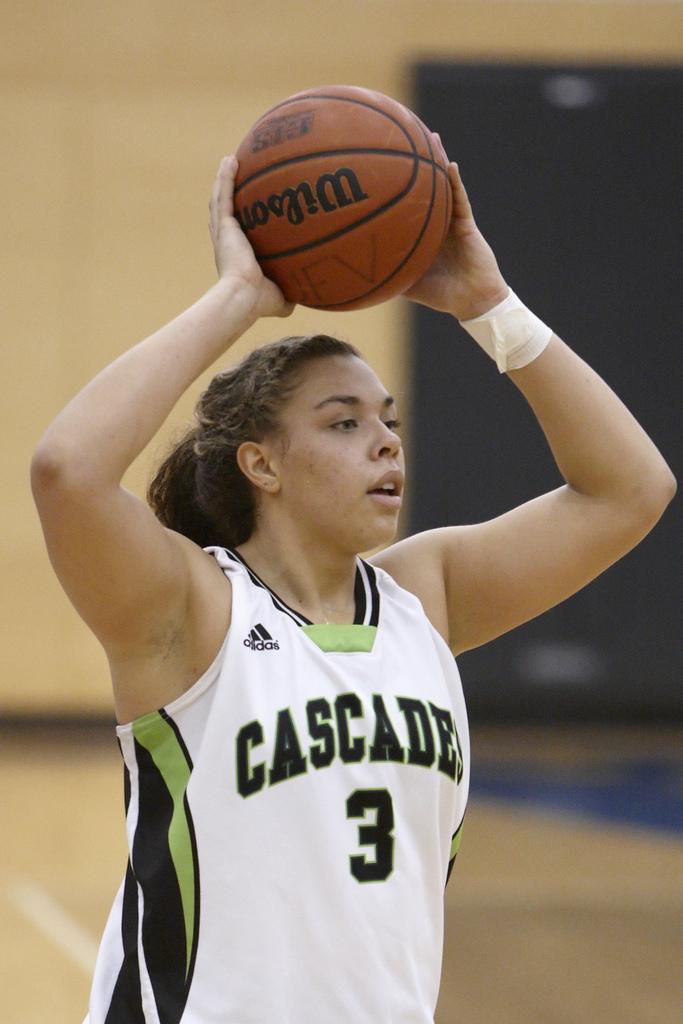What team does she play on?
Ensure brevity in your answer.  Cascade. 